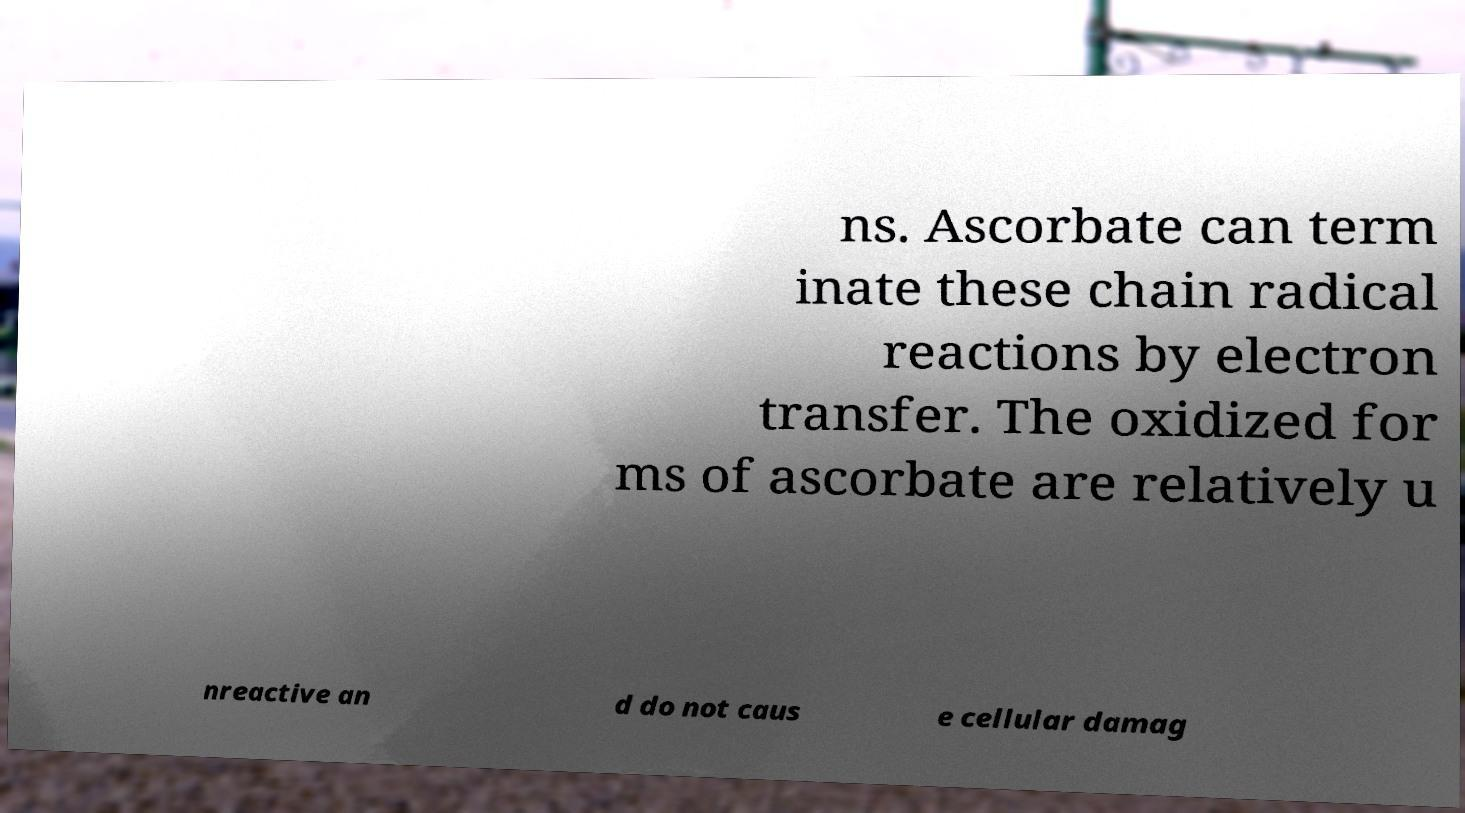There's text embedded in this image that I need extracted. Can you transcribe it verbatim? ns. Ascorbate can term inate these chain radical reactions by electron transfer. The oxidized for ms of ascorbate are relatively u nreactive an d do not caus e cellular damag 